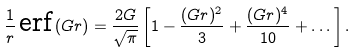Convert formula to latex. <formula><loc_0><loc_0><loc_500><loc_500>\frac { 1 } { r } \, \text {erf} \, ( G r ) = \frac { 2 G } { \sqrt { \pi } } \left [ 1 - \frac { ( G r ) ^ { 2 } } { 3 } + \frac { ( G r ) ^ { 4 } } { 1 0 } + \dots \right ] .</formula> 